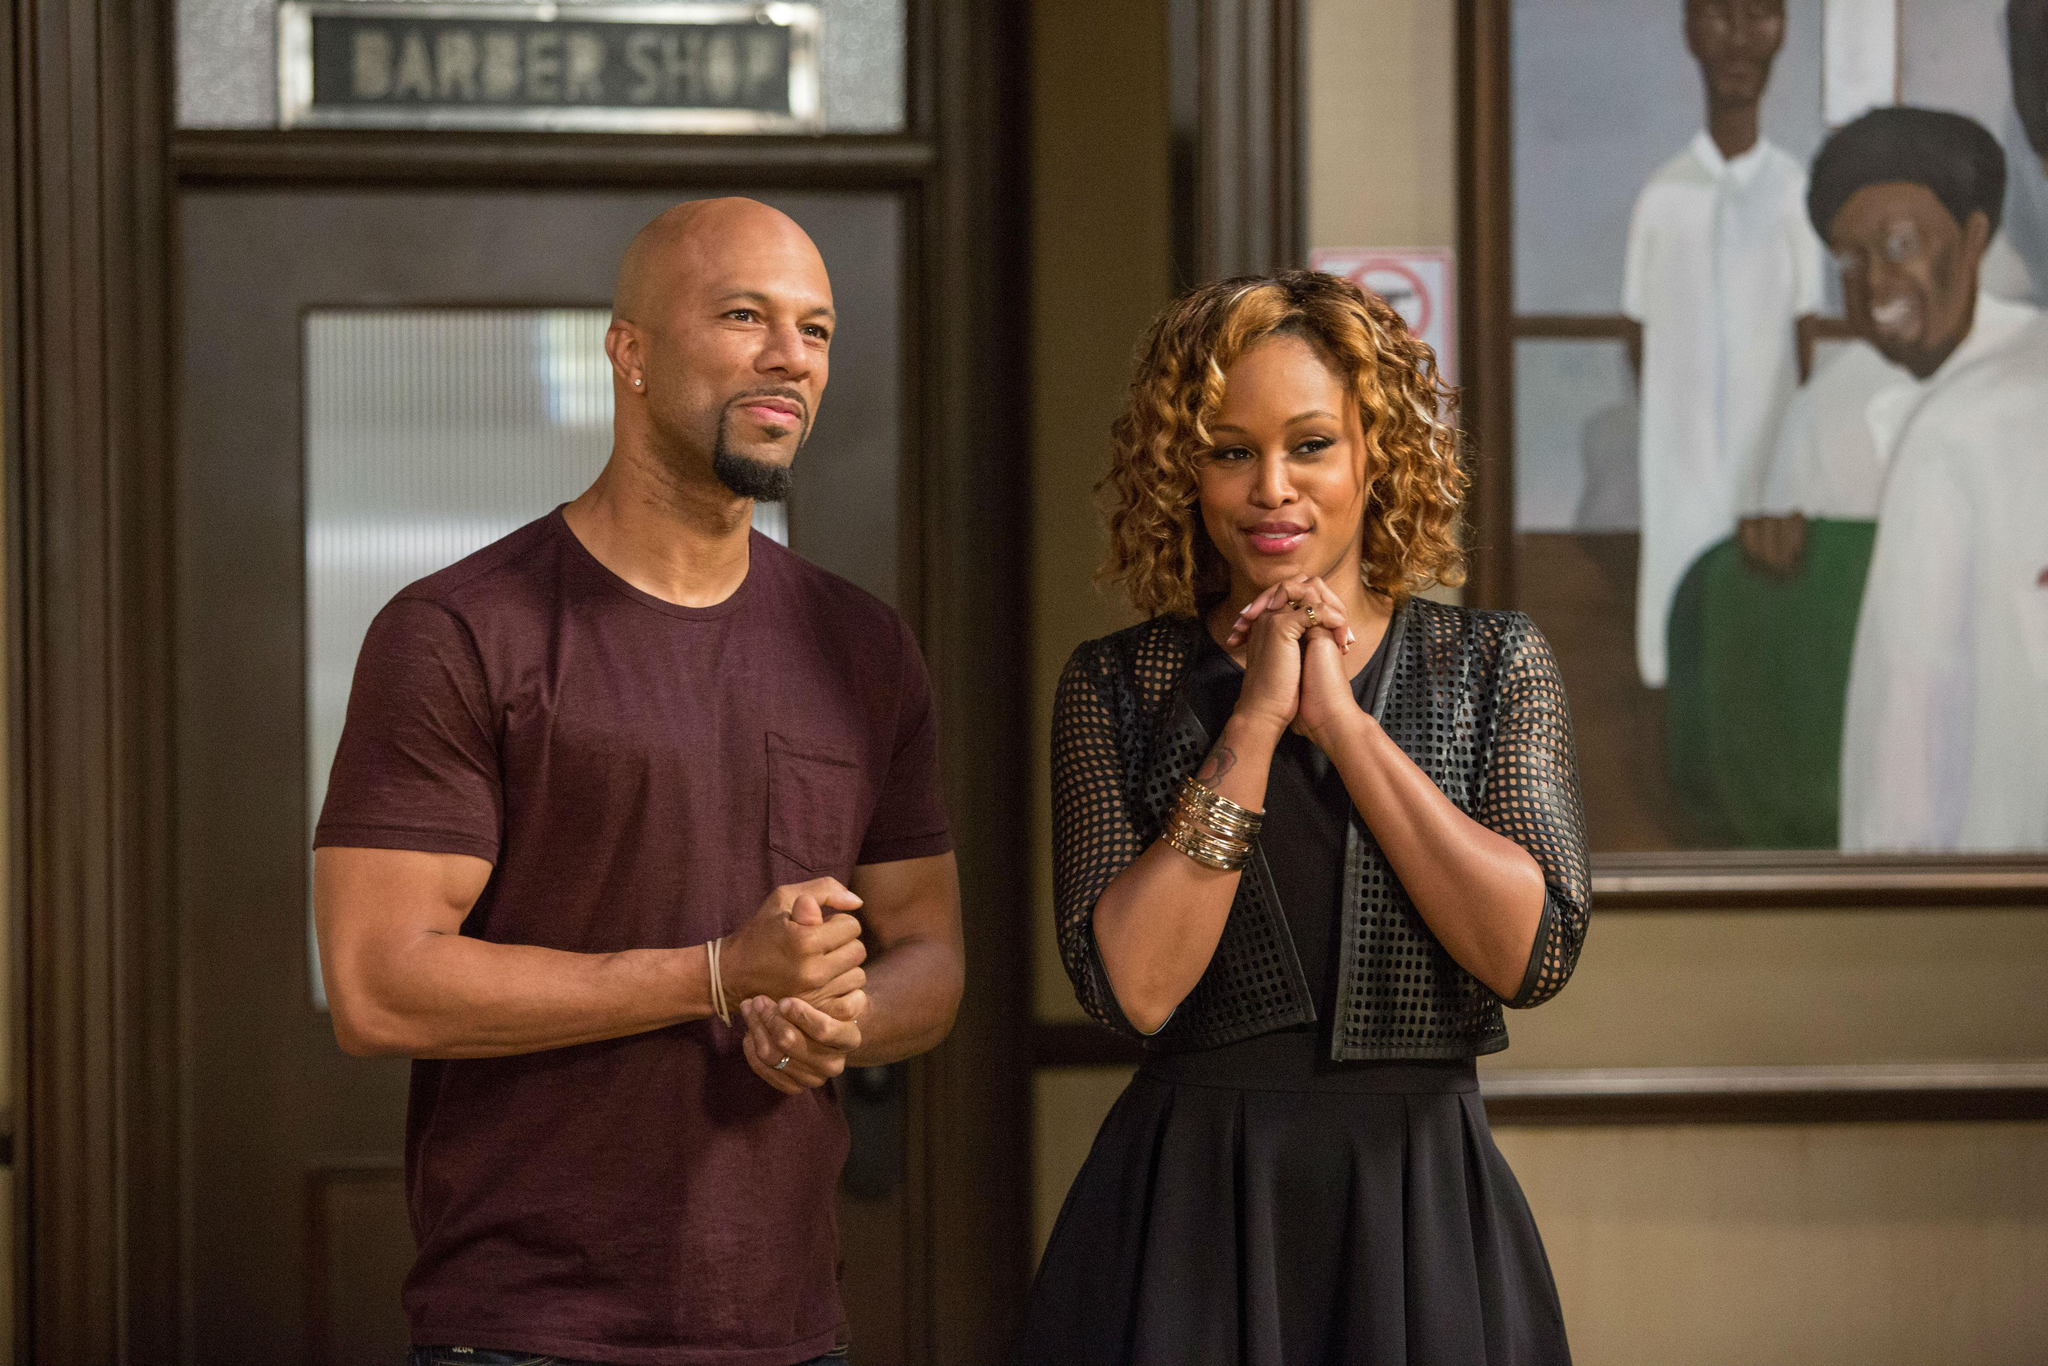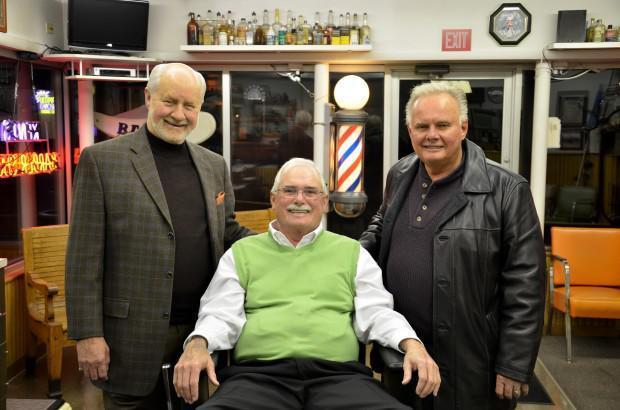The first image is the image on the left, the second image is the image on the right. Analyze the images presented: Is the assertion "A female wearing black stands in the foreground of the image on the left." valid? Answer yes or no. Yes. The first image is the image on the left, the second image is the image on the right. For the images displayed, is the sentence "One man is sitting between two other men in the image on the right." factually correct? Answer yes or no. Yes. 